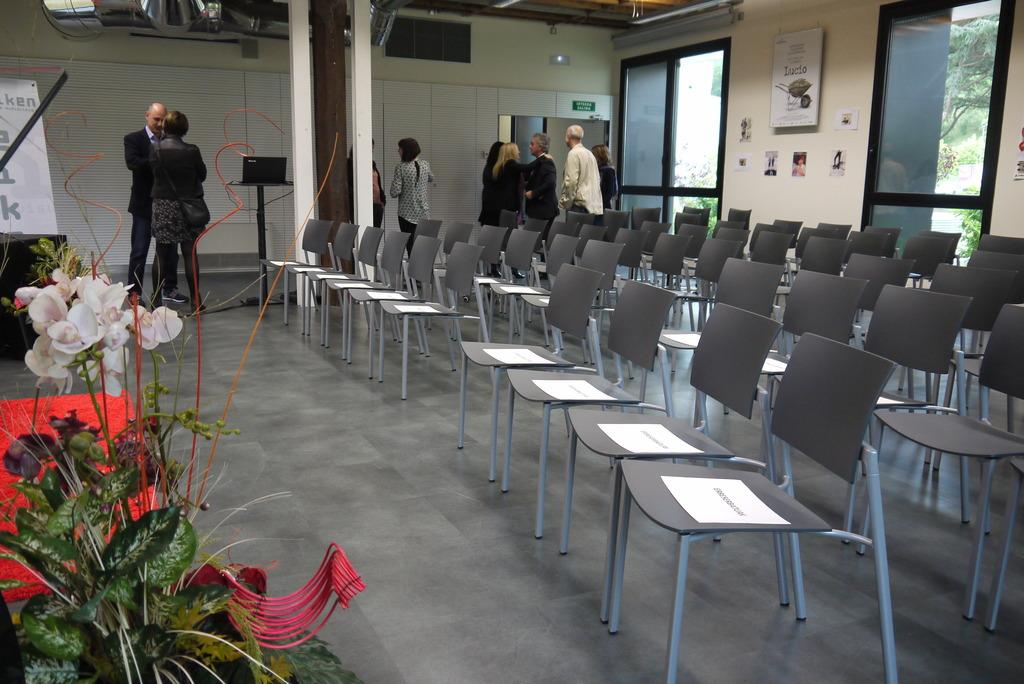Who or what is present in the image? There are people in the image. What objects are in the image that people might sit on? There are chairs in the image. Is there any natural element or decoration in the image? Yes, there is a flower in the image. What type of architectural feature can be seen in the image? There are glass doors in the image. Can you see a rabbit playing with a tooth in the image? No, there is no rabbit or tooth present in the image. 